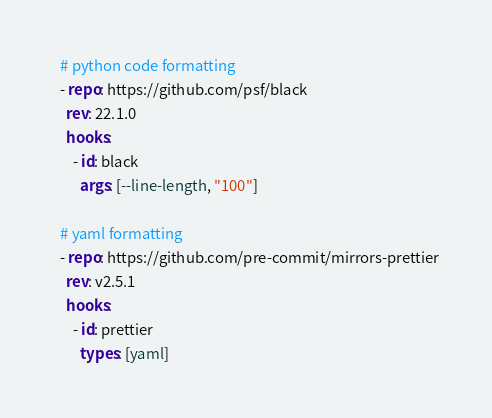<code> <loc_0><loc_0><loc_500><loc_500><_YAML_>  # python code formatting
  - repo: https://github.com/psf/black
    rev: 22.1.0
    hooks:
      - id: black
        args: [--line-length, "100"]

  # yaml formatting
  - repo: https://github.com/pre-commit/mirrors-prettier
    rev: v2.5.1
    hooks:
      - id: prettier
        types: [yaml]
</code> 